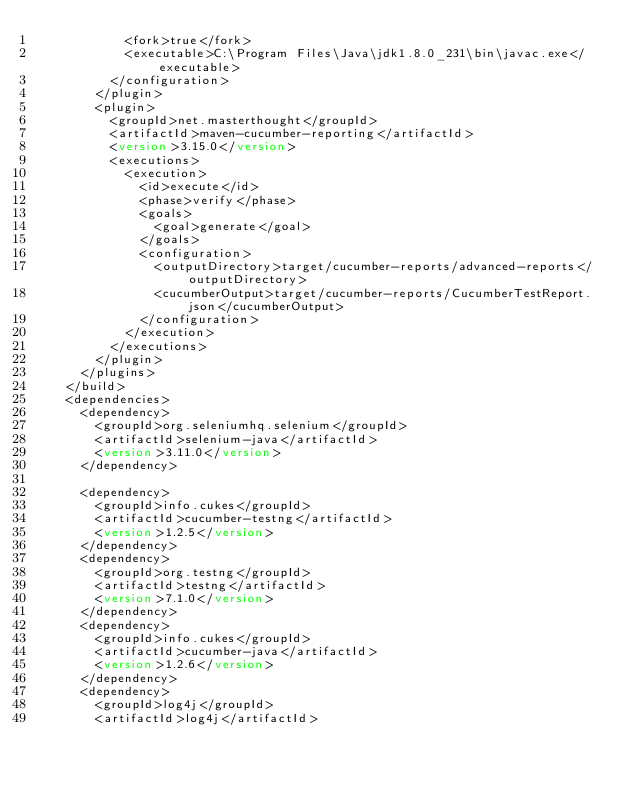Convert code to text. <code><loc_0><loc_0><loc_500><loc_500><_XML_>  					<fork>true</fork>
  					<executable>C:\Program Files\Java\jdk1.8.0_231\bin\javac.exe</executable>
  				</configuration>
  			</plugin>
  			<plugin>
  				<groupId>net.masterthought</groupId>
  				<artifactId>maven-cucumber-reporting</artifactId>
  				<version>3.15.0</version>
  				<executions>
  					<execution>
  						<id>execute</id>
  						<phase>verify</phase>
  						<goals>
  							<goal>generate</goal>
  						</goals>
  						<configuration>
  							<outputDirectory>target/cucumber-reports/advanced-reports</outputDirectory>
  							<cucumberOutput>target/cucumber-reports/CucumberTestReport.json</cucumberOutput>
  						</configuration>
  					</execution>
  				</executions>
  			</plugin>
  		</plugins>
  	</build>
  	<dependencies>
  		<dependency>
  			<groupId>org.seleniumhq.selenium</groupId>
  			<artifactId>selenium-java</artifactId>
  			<version>3.11.0</version>
  		</dependency>
  		
  		<dependency>
  			<groupId>info.cukes</groupId>
  			<artifactId>cucumber-testng</artifactId>
  			<version>1.2.5</version>
  		</dependency>
  		<dependency>
  			<groupId>org.testng</groupId>
  			<artifactId>testng</artifactId>
  			<version>7.1.0</version>
  		</dependency>
  		<dependency>
  			<groupId>info.cukes</groupId>
  			<artifactId>cucumber-java</artifactId>
  			<version>1.2.6</version>
  		</dependency>
  		<dependency>
  			<groupId>log4j</groupId>
  			<artifactId>log4j</artifactId></code> 